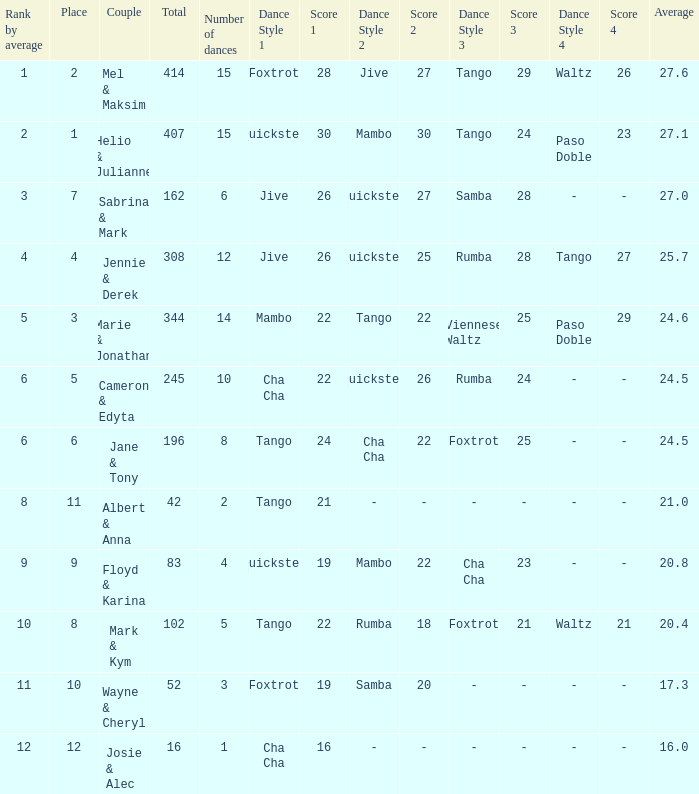What is the smallest place number when the total is 16 and average is less than 16? None. 